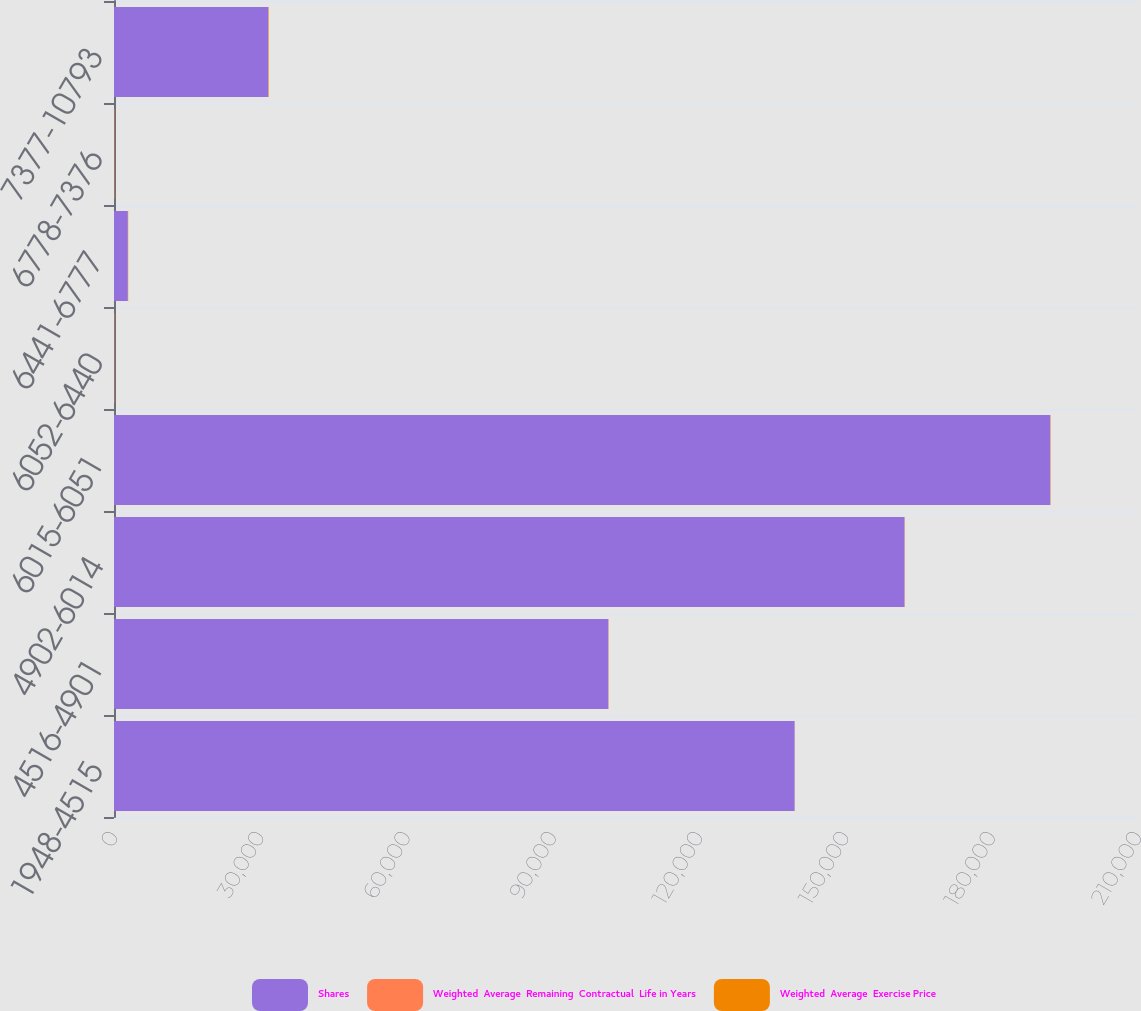Convert chart. <chart><loc_0><loc_0><loc_500><loc_500><stacked_bar_chart><ecel><fcel>1948-4515<fcel>4516-4901<fcel>4902-6014<fcel>6015-6051<fcel>6052-6440<fcel>6441-6777<fcel>6778-7376<fcel>7377-10793<nl><fcel>Shares<fcel>139582<fcel>101374<fcel>162117<fcel>191999<fcel>55.63<fcel>2842<fcel>55.63<fcel>31639<nl><fcel>Weighted  Average  Remaining  Contractual  Life in Years<fcel>1.55<fcel>1.64<fcel>2.66<fcel>3.32<fcel>4.33<fcel>4.25<fcel>5.33<fcel>6.31<nl><fcel>Weighted  Average  Exercise Price<fcel>23.86<fcel>46.98<fcel>50.89<fcel>60.37<fcel>64.31<fcel>64.43<fcel>71.11<fcel>99.24<nl></chart> 